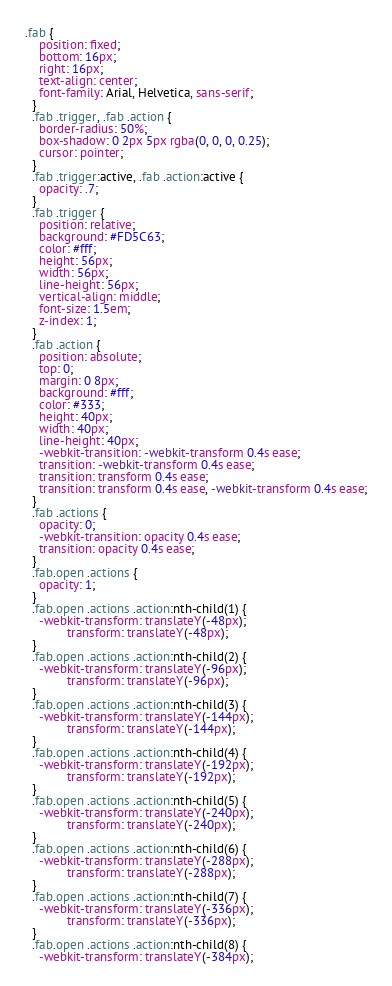<code> <loc_0><loc_0><loc_500><loc_500><_CSS_>.fab {
    position: fixed;
    bottom: 16px;
    right: 16px;
    text-align: center;
    font-family: Arial, Helvetica, sans-serif;
  }
  .fab .trigger, .fab .action {
    border-radius: 50%;
    box-shadow: 0 2px 5px rgba(0, 0, 0, 0.25);
    cursor: pointer;
  }
  .fab .trigger:active, .fab .action:active {
    opacity: .7;
  }
  .fab .trigger {
    position: relative;
    background: #FD5C63;
    color: #fff;
    height: 56px;
    width: 56px;
    line-height: 56px;
    vertical-align: middle;
    font-size: 1.5em;
    z-index: 1;
  }
  .fab .action {
    position: absolute;
    top: 0;
    margin: 0 8px;
    background: #fff;
    color: #333;
    height: 40px;
    width: 40px;
    line-height: 40px;
    -webkit-transition: -webkit-transform 0.4s ease;
    transition: -webkit-transform 0.4s ease;
    transition: transform 0.4s ease;
    transition: transform 0.4s ease, -webkit-transform 0.4s ease;
  }
  .fab .actions {
    opacity: 0;
    -webkit-transition: opacity 0.4s ease;
    transition: opacity 0.4s ease;
  }
  .fab.open .actions {
    opacity: 1;
  }
  .fab.open .actions .action:nth-child(1) {
    -webkit-transform: translateY(-48px);
            transform: translateY(-48px);
  }
  .fab.open .actions .action:nth-child(2) {
    -webkit-transform: translateY(-96px);
            transform: translateY(-96px);
  }
  .fab.open .actions .action:nth-child(3) {
    -webkit-transform: translateY(-144px);
            transform: translateY(-144px);
  }
  .fab.open .actions .action:nth-child(4) {
    -webkit-transform: translateY(-192px);
            transform: translateY(-192px);
  }
  .fab.open .actions .action:nth-child(5) {
    -webkit-transform: translateY(-240px);
            transform: translateY(-240px);
  }
  .fab.open .actions .action:nth-child(6) {
    -webkit-transform: translateY(-288px);
            transform: translateY(-288px);
  }
  .fab.open .actions .action:nth-child(7) {
    -webkit-transform: translateY(-336px);
            transform: translateY(-336px);
  }
  .fab.open .actions .action:nth-child(8) {
    -webkit-transform: translateY(-384px);</code> 